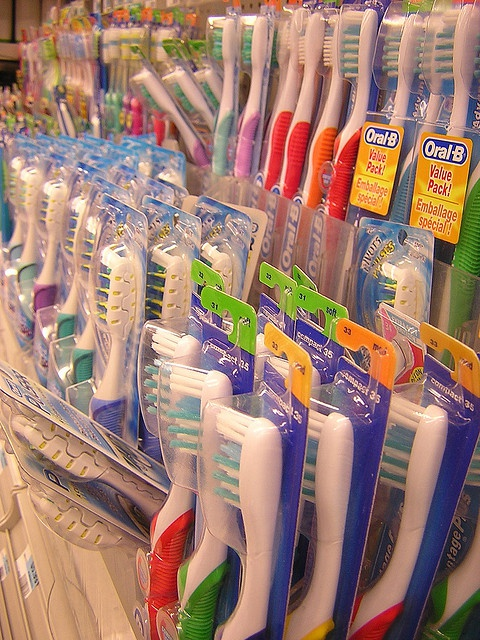Describe the objects in this image and their specific colors. I can see toothbrush in maroon, tan, gray, and darkgray tones, toothbrush in maroon, tan, darkgray, red, and brown tones, toothbrush in maroon, salmon, gray, and tan tones, toothbrush in maroon, tan, darkgray, and beige tones, and toothbrush in maroon, tan, salmon, and gray tones in this image. 